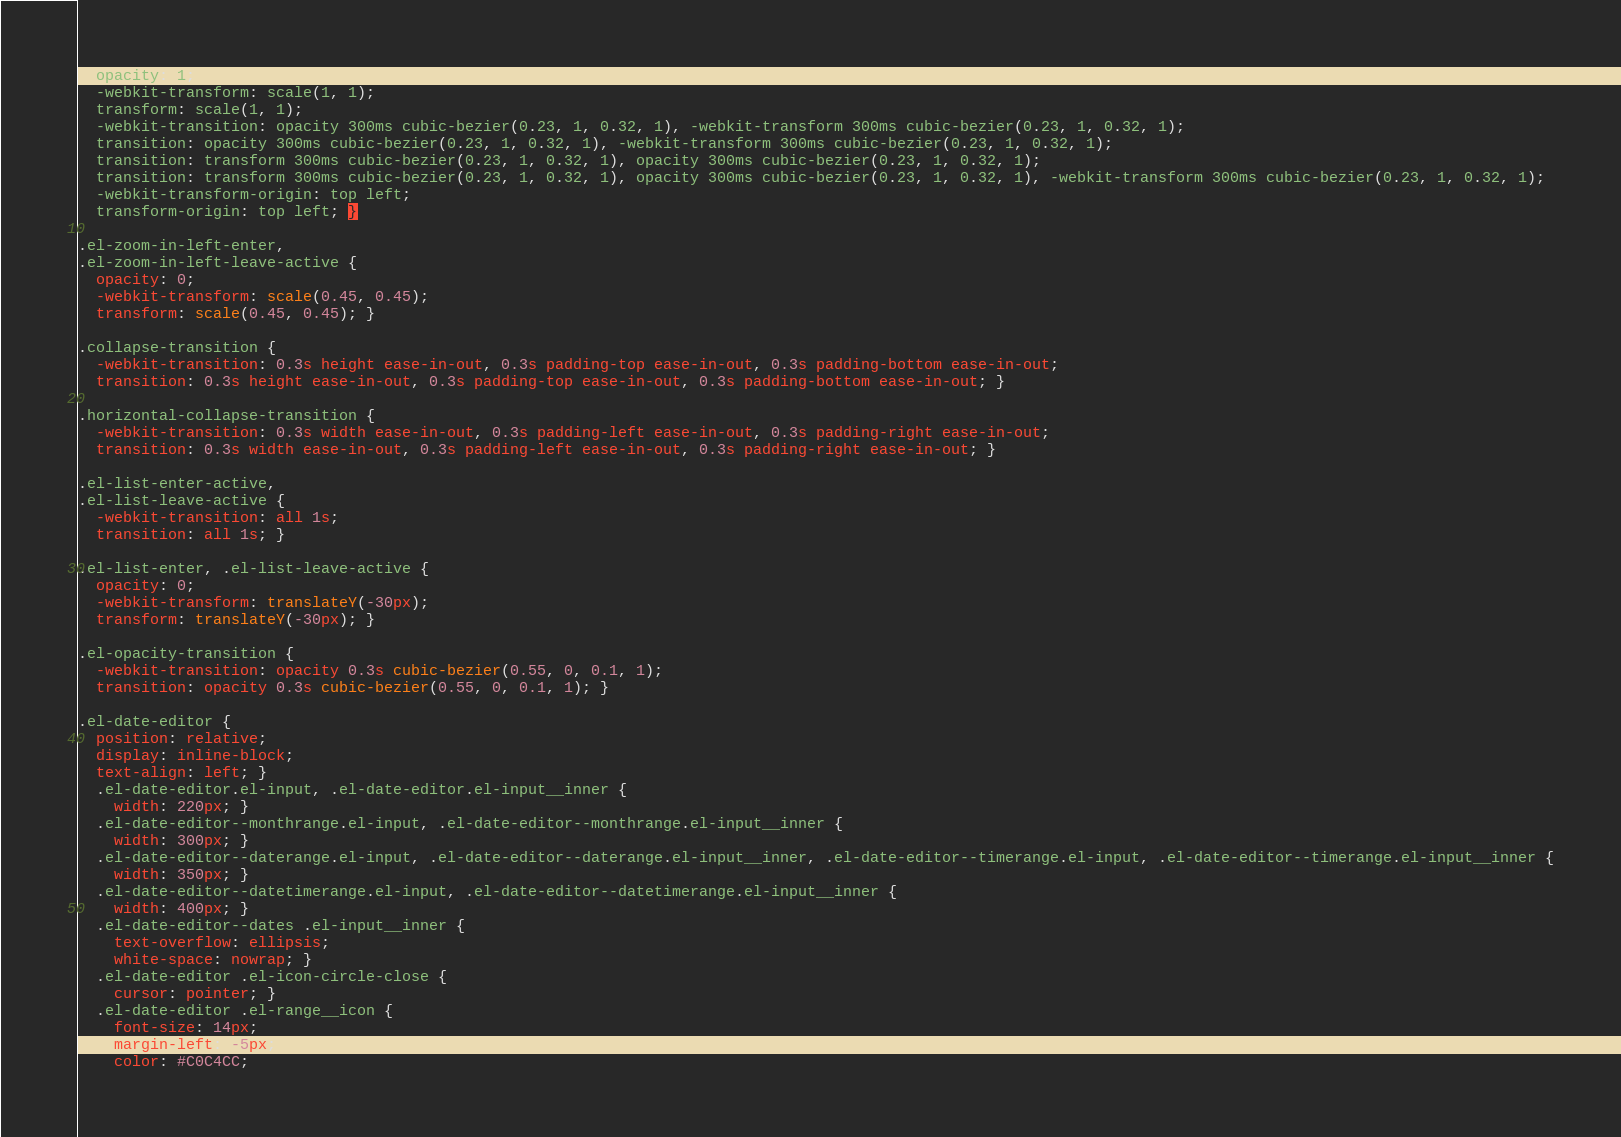Convert code to text. <code><loc_0><loc_0><loc_500><loc_500><_CSS_>  opacity: 1;
  -webkit-transform: scale(1, 1);
  transform: scale(1, 1);
  -webkit-transition: opacity 300ms cubic-bezier(0.23, 1, 0.32, 1), -webkit-transform 300ms cubic-bezier(0.23, 1, 0.32, 1);
  transition: opacity 300ms cubic-bezier(0.23, 1, 0.32, 1), -webkit-transform 300ms cubic-bezier(0.23, 1, 0.32, 1);
  transition: transform 300ms cubic-bezier(0.23, 1, 0.32, 1), opacity 300ms cubic-bezier(0.23, 1, 0.32, 1);
  transition: transform 300ms cubic-bezier(0.23, 1, 0.32, 1), opacity 300ms cubic-bezier(0.23, 1, 0.32, 1), -webkit-transform 300ms cubic-bezier(0.23, 1, 0.32, 1);
  -webkit-transform-origin: top left;
  transform-origin: top left; }

.el-zoom-in-left-enter,
.el-zoom-in-left-leave-active {
  opacity: 0;
  -webkit-transform: scale(0.45, 0.45);
  transform: scale(0.45, 0.45); }

.collapse-transition {
  -webkit-transition: 0.3s height ease-in-out, 0.3s padding-top ease-in-out, 0.3s padding-bottom ease-in-out;
  transition: 0.3s height ease-in-out, 0.3s padding-top ease-in-out, 0.3s padding-bottom ease-in-out; }

.horizontal-collapse-transition {
  -webkit-transition: 0.3s width ease-in-out, 0.3s padding-left ease-in-out, 0.3s padding-right ease-in-out;
  transition: 0.3s width ease-in-out, 0.3s padding-left ease-in-out, 0.3s padding-right ease-in-out; }

.el-list-enter-active,
.el-list-leave-active {
  -webkit-transition: all 1s;
  transition: all 1s; }

.el-list-enter, .el-list-leave-active {
  opacity: 0;
  -webkit-transform: translateY(-30px);
  transform: translateY(-30px); }

.el-opacity-transition {
  -webkit-transition: opacity 0.3s cubic-bezier(0.55, 0, 0.1, 1);
  transition: opacity 0.3s cubic-bezier(0.55, 0, 0.1, 1); }

.el-date-editor {
  position: relative;
  display: inline-block;
  text-align: left; }
  .el-date-editor.el-input, .el-date-editor.el-input__inner {
    width: 220px; }
  .el-date-editor--monthrange.el-input, .el-date-editor--monthrange.el-input__inner {
    width: 300px; }
  .el-date-editor--daterange.el-input, .el-date-editor--daterange.el-input__inner, .el-date-editor--timerange.el-input, .el-date-editor--timerange.el-input__inner {
    width: 350px; }
  .el-date-editor--datetimerange.el-input, .el-date-editor--datetimerange.el-input__inner {
    width: 400px; }
  .el-date-editor--dates .el-input__inner {
    text-overflow: ellipsis;
    white-space: nowrap; }
  .el-date-editor .el-icon-circle-close {
    cursor: pointer; }
  .el-date-editor .el-range__icon {
    font-size: 14px;
    margin-left: -5px;
    color: #C0C4CC;</code> 